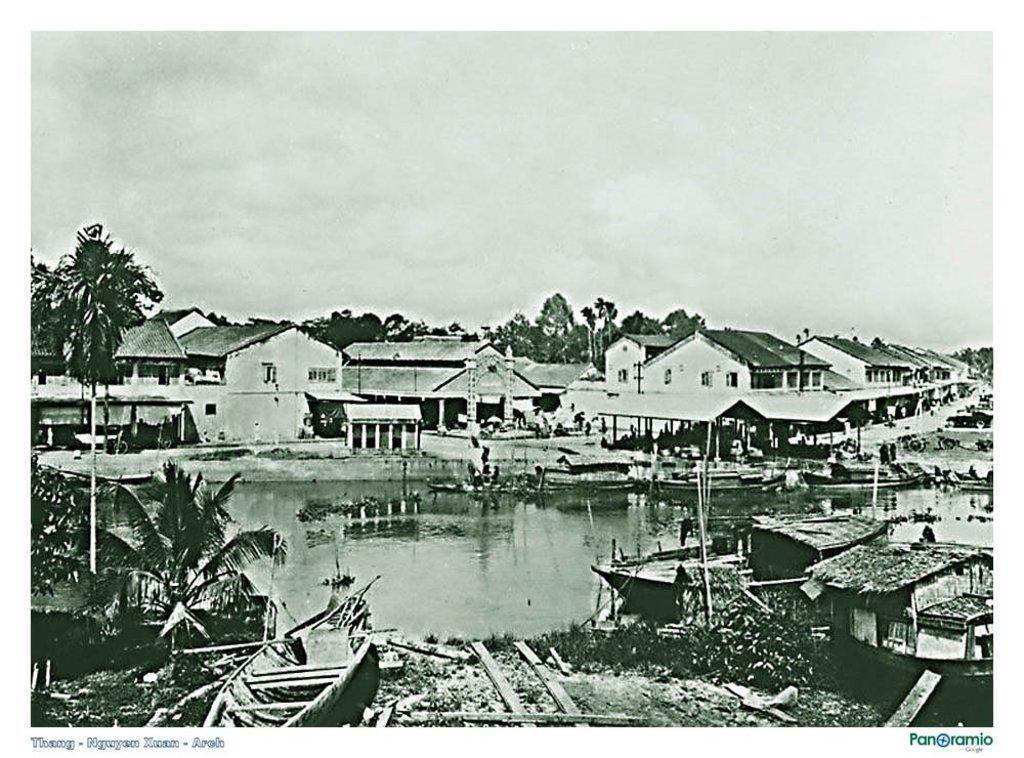What is the color scheme of the image? The image is black and white. What natural feature can be seen in the image? There is a lake in the image. What structures are located behind the lake? Buildings are present behind the lake are present in the image. What type of vegetation is visible behind the lake? Trees are present behind the lake. What is the condition of the sky in the image? The sky is full of clouds. What man-made objects can be seen near the lake? Boats are visible at the bottom of the image. Where is the key hidden in the image? There is no key present in the image. Can you see any hills in the image? There are no hills visible in the image. How many ants can be seen crawling on the boats in the image? There are no ants present in the image. 